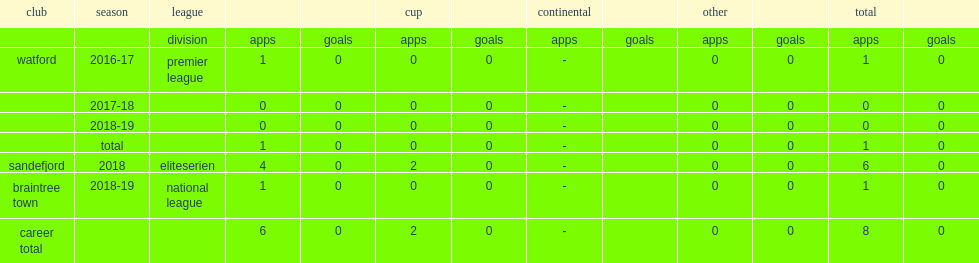In the 2016-17 season, which club debuted eleftheriou for the premier league? Watford. 